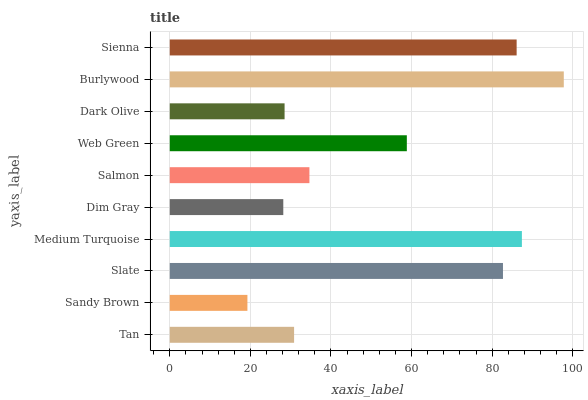Is Sandy Brown the minimum?
Answer yes or no. Yes. Is Burlywood the maximum?
Answer yes or no. Yes. Is Slate the minimum?
Answer yes or no. No. Is Slate the maximum?
Answer yes or no. No. Is Slate greater than Sandy Brown?
Answer yes or no. Yes. Is Sandy Brown less than Slate?
Answer yes or no. Yes. Is Sandy Brown greater than Slate?
Answer yes or no. No. Is Slate less than Sandy Brown?
Answer yes or no. No. Is Web Green the high median?
Answer yes or no. Yes. Is Salmon the low median?
Answer yes or no. Yes. Is Dim Gray the high median?
Answer yes or no. No. Is Burlywood the low median?
Answer yes or no. No. 